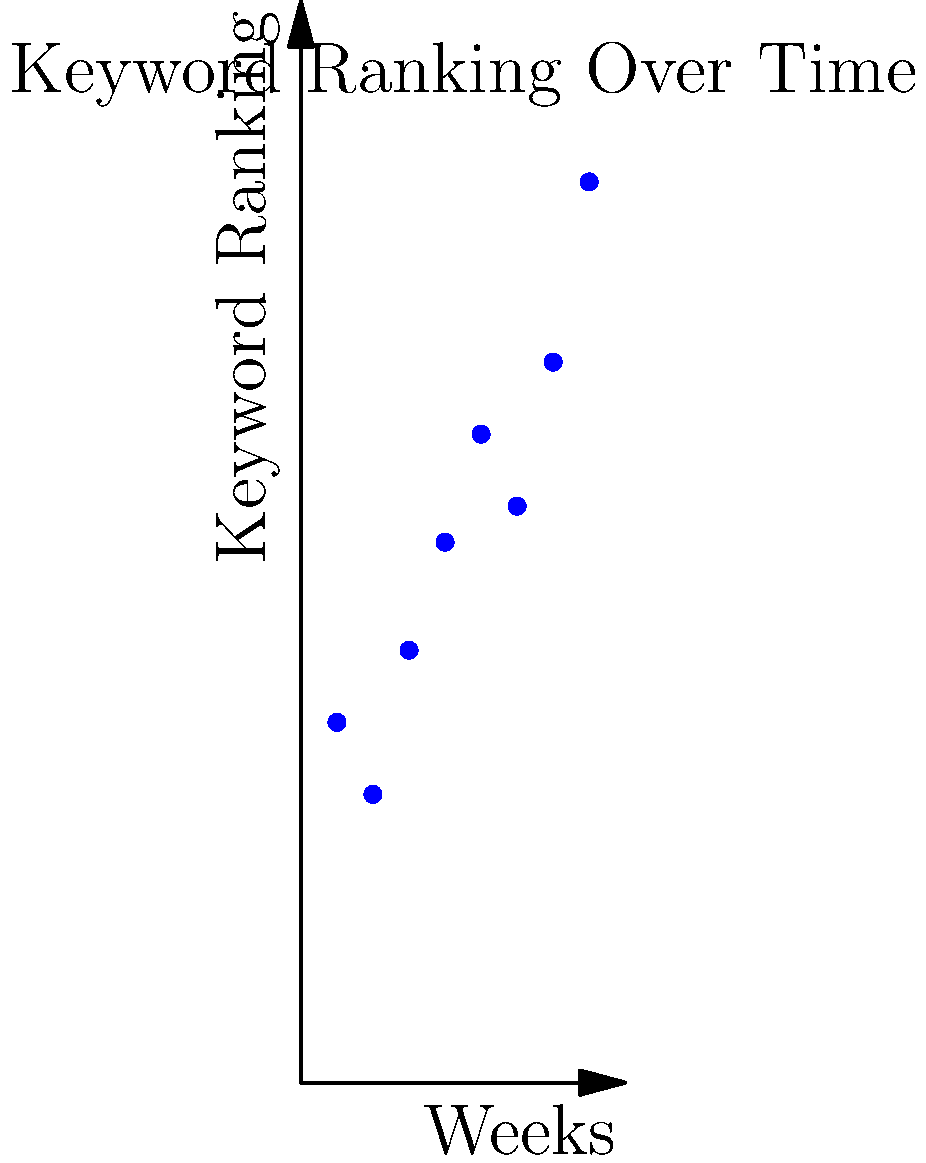Analiza el gráfico de dispersión que muestra el ranking de una palabra clave específica a lo largo de 8 semanas. Si la tendencia continúa, ¿cuál sería el ranking esperado para la semana 10, asumiendo un crecimiento lineal? Redondea tu respuesta al número entero más cercano. Para resolver este problema, seguiremos estos pasos:

1) Primero, observamos que hay una tendencia general al alza en el ranking de la palabra clave a lo largo del tiempo.

2) Para estimar el ranking en la semana 10, usaremos un modelo de regresión lineal simple.

3) La fórmula para la regresión lineal es $y = mx + b$, donde:
   $m$ es la pendiente
   $b$ es la intersección con el eje y
   $x$ es la variable independiente (semanas)
   $y$ es la variable dependiente (ranking)

4) Calculamos la pendiente ($m$) usando la fórmula:
   $m = \frac{n\sum(xy) - \sum x \sum y}{n\sum x^2 - (\sum x)^2}$

5) Calculamos la intersección ($b$) usando:
   $b = \frac{\sum y - m\sum x}{n}$

6) Usando una calculadora o una hoja de cálculo, obtenemos:
   $m \approx 2.0238$
   $b \approx 6.0714$

7) Por lo tanto, nuestra ecuación de regresión es:
   $y \approx 2.0238x + 6.0714$

8) Para la semana 10, sustituimos $x = 10$:
   $y \approx 2.0238(10) + 6.0714 \approx 26.3094$

9) Redondeando al número entero más cercano, obtenemos 26.
Answer: 26 